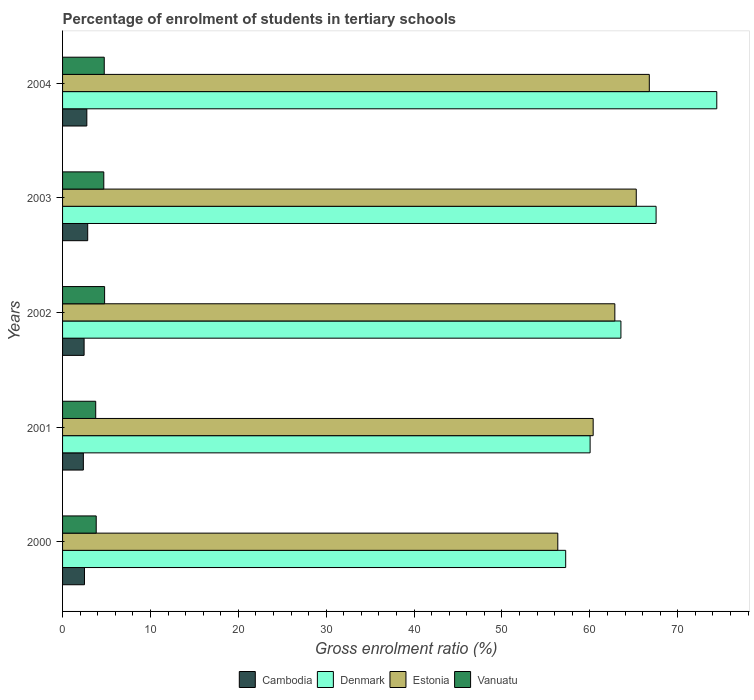How many groups of bars are there?
Offer a very short reply. 5. How many bars are there on the 2nd tick from the top?
Offer a terse response. 4. How many bars are there on the 4th tick from the bottom?
Offer a very short reply. 4. In how many cases, is the number of bars for a given year not equal to the number of legend labels?
Provide a short and direct response. 0. What is the percentage of students enrolled in tertiary schools in Vanuatu in 2003?
Your answer should be compact. 4.69. Across all years, what is the maximum percentage of students enrolled in tertiary schools in Cambodia?
Your answer should be compact. 2.86. Across all years, what is the minimum percentage of students enrolled in tertiary schools in Denmark?
Your response must be concise. 57.25. In which year was the percentage of students enrolled in tertiary schools in Denmark maximum?
Your answer should be compact. 2004. What is the total percentage of students enrolled in tertiary schools in Cambodia in the graph?
Offer a very short reply. 12.93. What is the difference between the percentage of students enrolled in tertiary schools in Estonia in 2003 and that in 2004?
Keep it short and to the point. -1.49. What is the difference between the percentage of students enrolled in tertiary schools in Cambodia in 2004 and the percentage of students enrolled in tertiary schools in Vanuatu in 2001?
Ensure brevity in your answer.  -1.01. What is the average percentage of students enrolled in tertiary schools in Vanuatu per year?
Ensure brevity in your answer.  4.36. In the year 2003, what is the difference between the percentage of students enrolled in tertiary schools in Denmark and percentage of students enrolled in tertiary schools in Cambodia?
Offer a terse response. 64.68. What is the ratio of the percentage of students enrolled in tertiary schools in Cambodia in 2002 to that in 2003?
Ensure brevity in your answer.  0.86. Is the difference between the percentage of students enrolled in tertiary schools in Denmark in 2000 and 2003 greater than the difference between the percentage of students enrolled in tertiary schools in Cambodia in 2000 and 2003?
Make the answer very short. No. What is the difference between the highest and the second highest percentage of students enrolled in tertiary schools in Denmark?
Make the answer very short. 6.91. What is the difference between the highest and the lowest percentage of students enrolled in tertiary schools in Denmark?
Your answer should be compact. 17.19. Is the sum of the percentage of students enrolled in tertiary schools in Denmark in 2000 and 2004 greater than the maximum percentage of students enrolled in tertiary schools in Estonia across all years?
Your answer should be compact. Yes. Is it the case that in every year, the sum of the percentage of students enrolled in tertiary schools in Vanuatu and percentage of students enrolled in tertiary schools in Denmark is greater than the sum of percentage of students enrolled in tertiary schools in Cambodia and percentage of students enrolled in tertiary schools in Estonia?
Your response must be concise. Yes. What does the 3rd bar from the bottom in 2000 represents?
Keep it short and to the point. Estonia. Are all the bars in the graph horizontal?
Offer a terse response. Yes. Does the graph contain any zero values?
Offer a terse response. No. What is the title of the graph?
Offer a very short reply. Percentage of enrolment of students in tertiary schools. What is the label or title of the X-axis?
Offer a terse response. Gross enrolment ratio (%). What is the label or title of the Y-axis?
Ensure brevity in your answer.  Years. What is the Gross enrolment ratio (%) in Cambodia in 2000?
Your response must be concise. 2.49. What is the Gross enrolment ratio (%) in Denmark in 2000?
Provide a succinct answer. 57.25. What is the Gross enrolment ratio (%) in Estonia in 2000?
Offer a terse response. 56.35. What is the Gross enrolment ratio (%) of Vanuatu in 2000?
Provide a short and direct response. 3.83. What is the Gross enrolment ratio (%) of Cambodia in 2001?
Offer a very short reply. 2.37. What is the Gross enrolment ratio (%) of Denmark in 2001?
Keep it short and to the point. 60.03. What is the Gross enrolment ratio (%) in Estonia in 2001?
Your answer should be compact. 60.38. What is the Gross enrolment ratio (%) in Vanuatu in 2001?
Your answer should be very brief. 3.77. What is the Gross enrolment ratio (%) in Cambodia in 2002?
Ensure brevity in your answer.  2.45. What is the Gross enrolment ratio (%) of Denmark in 2002?
Make the answer very short. 63.54. What is the Gross enrolment ratio (%) of Estonia in 2002?
Provide a short and direct response. 62.84. What is the Gross enrolment ratio (%) in Vanuatu in 2002?
Your answer should be compact. 4.78. What is the Gross enrolment ratio (%) of Cambodia in 2003?
Keep it short and to the point. 2.86. What is the Gross enrolment ratio (%) of Denmark in 2003?
Ensure brevity in your answer.  67.54. What is the Gross enrolment ratio (%) in Estonia in 2003?
Give a very brief answer. 65.28. What is the Gross enrolment ratio (%) in Vanuatu in 2003?
Your answer should be compact. 4.69. What is the Gross enrolment ratio (%) in Cambodia in 2004?
Give a very brief answer. 2.76. What is the Gross enrolment ratio (%) of Denmark in 2004?
Your answer should be compact. 74.44. What is the Gross enrolment ratio (%) of Estonia in 2004?
Your answer should be very brief. 66.77. What is the Gross enrolment ratio (%) in Vanuatu in 2004?
Offer a very short reply. 4.74. Across all years, what is the maximum Gross enrolment ratio (%) of Cambodia?
Offer a very short reply. 2.86. Across all years, what is the maximum Gross enrolment ratio (%) in Denmark?
Your answer should be compact. 74.44. Across all years, what is the maximum Gross enrolment ratio (%) in Estonia?
Give a very brief answer. 66.77. Across all years, what is the maximum Gross enrolment ratio (%) of Vanuatu?
Provide a succinct answer. 4.78. Across all years, what is the minimum Gross enrolment ratio (%) in Cambodia?
Offer a terse response. 2.37. Across all years, what is the minimum Gross enrolment ratio (%) of Denmark?
Provide a succinct answer. 57.25. Across all years, what is the minimum Gross enrolment ratio (%) in Estonia?
Your answer should be compact. 56.35. Across all years, what is the minimum Gross enrolment ratio (%) in Vanuatu?
Ensure brevity in your answer.  3.77. What is the total Gross enrolment ratio (%) in Cambodia in the graph?
Your answer should be very brief. 12.93. What is the total Gross enrolment ratio (%) in Denmark in the graph?
Provide a short and direct response. 322.79. What is the total Gross enrolment ratio (%) in Estonia in the graph?
Your answer should be compact. 311.62. What is the total Gross enrolment ratio (%) in Vanuatu in the graph?
Your answer should be very brief. 21.82. What is the difference between the Gross enrolment ratio (%) in Cambodia in 2000 and that in 2001?
Offer a terse response. 0.13. What is the difference between the Gross enrolment ratio (%) in Denmark in 2000 and that in 2001?
Provide a short and direct response. -2.78. What is the difference between the Gross enrolment ratio (%) in Estonia in 2000 and that in 2001?
Ensure brevity in your answer.  -4.03. What is the difference between the Gross enrolment ratio (%) of Vanuatu in 2000 and that in 2001?
Provide a short and direct response. 0.06. What is the difference between the Gross enrolment ratio (%) of Cambodia in 2000 and that in 2002?
Make the answer very short. 0.04. What is the difference between the Gross enrolment ratio (%) in Denmark in 2000 and that in 2002?
Your answer should be very brief. -6.29. What is the difference between the Gross enrolment ratio (%) of Estonia in 2000 and that in 2002?
Keep it short and to the point. -6.49. What is the difference between the Gross enrolment ratio (%) of Vanuatu in 2000 and that in 2002?
Provide a succinct answer. -0.95. What is the difference between the Gross enrolment ratio (%) of Cambodia in 2000 and that in 2003?
Make the answer very short. -0.37. What is the difference between the Gross enrolment ratio (%) of Denmark in 2000 and that in 2003?
Provide a short and direct response. -10.29. What is the difference between the Gross enrolment ratio (%) of Estonia in 2000 and that in 2003?
Ensure brevity in your answer.  -8.93. What is the difference between the Gross enrolment ratio (%) in Vanuatu in 2000 and that in 2003?
Your answer should be very brief. -0.86. What is the difference between the Gross enrolment ratio (%) in Cambodia in 2000 and that in 2004?
Give a very brief answer. -0.27. What is the difference between the Gross enrolment ratio (%) in Denmark in 2000 and that in 2004?
Keep it short and to the point. -17.19. What is the difference between the Gross enrolment ratio (%) in Estonia in 2000 and that in 2004?
Give a very brief answer. -10.41. What is the difference between the Gross enrolment ratio (%) of Vanuatu in 2000 and that in 2004?
Your response must be concise. -0.91. What is the difference between the Gross enrolment ratio (%) of Cambodia in 2001 and that in 2002?
Your answer should be compact. -0.08. What is the difference between the Gross enrolment ratio (%) of Denmark in 2001 and that in 2002?
Give a very brief answer. -3.51. What is the difference between the Gross enrolment ratio (%) of Estonia in 2001 and that in 2002?
Your answer should be compact. -2.47. What is the difference between the Gross enrolment ratio (%) in Vanuatu in 2001 and that in 2002?
Ensure brevity in your answer.  -1.01. What is the difference between the Gross enrolment ratio (%) in Cambodia in 2001 and that in 2003?
Provide a short and direct response. -0.49. What is the difference between the Gross enrolment ratio (%) of Denmark in 2001 and that in 2003?
Your answer should be very brief. -7.51. What is the difference between the Gross enrolment ratio (%) of Estonia in 2001 and that in 2003?
Give a very brief answer. -4.9. What is the difference between the Gross enrolment ratio (%) of Vanuatu in 2001 and that in 2003?
Your answer should be compact. -0.92. What is the difference between the Gross enrolment ratio (%) of Cambodia in 2001 and that in 2004?
Your answer should be very brief. -0.39. What is the difference between the Gross enrolment ratio (%) of Denmark in 2001 and that in 2004?
Offer a terse response. -14.41. What is the difference between the Gross enrolment ratio (%) in Estonia in 2001 and that in 2004?
Your answer should be compact. -6.39. What is the difference between the Gross enrolment ratio (%) of Vanuatu in 2001 and that in 2004?
Your response must be concise. -0.97. What is the difference between the Gross enrolment ratio (%) in Cambodia in 2002 and that in 2003?
Your answer should be compact. -0.41. What is the difference between the Gross enrolment ratio (%) in Denmark in 2002 and that in 2003?
Offer a very short reply. -4. What is the difference between the Gross enrolment ratio (%) of Estonia in 2002 and that in 2003?
Your response must be concise. -2.44. What is the difference between the Gross enrolment ratio (%) of Vanuatu in 2002 and that in 2003?
Provide a short and direct response. 0.09. What is the difference between the Gross enrolment ratio (%) in Cambodia in 2002 and that in 2004?
Give a very brief answer. -0.31. What is the difference between the Gross enrolment ratio (%) in Denmark in 2002 and that in 2004?
Give a very brief answer. -10.91. What is the difference between the Gross enrolment ratio (%) of Estonia in 2002 and that in 2004?
Your answer should be very brief. -3.92. What is the difference between the Gross enrolment ratio (%) in Vanuatu in 2002 and that in 2004?
Give a very brief answer. 0.04. What is the difference between the Gross enrolment ratio (%) of Cambodia in 2003 and that in 2004?
Provide a short and direct response. 0.1. What is the difference between the Gross enrolment ratio (%) in Denmark in 2003 and that in 2004?
Provide a short and direct response. -6.91. What is the difference between the Gross enrolment ratio (%) of Estonia in 2003 and that in 2004?
Your response must be concise. -1.49. What is the difference between the Gross enrolment ratio (%) in Vanuatu in 2003 and that in 2004?
Keep it short and to the point. -0.05. What is the difference between the Gross enrolment ratio (%) in Cambodia in 2000 and the Gross enrolment ratio (%) in Denmark in 2001?
Make the answer very short. -57.53. What is the difference between the Gross enrolment ratio (%) in Cambodia in 2000 and the Gross enrolment ratio (%) in Estonia in 2001?
Make the answer very short. -57.88. What is the difference between the Gross enrolment ratio (%) in Cambodia in 2000 and the Gross enrolment ratio (%) in Vanuatu in 2001?
Ensure brevity in your answer.  -1.28. What is the difference between the Gross enrolment ratio (%) of Denmark in 2000 and the Gross enrolment ratio (%) of Estonia in 2001?
Give a very brief answer. -3.13. What is the difference between the Gross enrolment ratio (%) of Denmark in 2000 and the Gross enrolment ratio (%) of Vanuatu in 2001?
Your answer should be compact. 53.48. What is the difference between the Gross enrolment ratio (%) in Estonia in 2000 and the Gross enrolment ratio (%) in Vanuatu in 2001?
Ensure brevity in your answer.  52.58. What is the difference between the Gross enrolment ratio (%) in Cambodia in 2000 and the Gross enrolment ratio (%) in Denmark in 2002?
Ensure brevity in your answer.  -61.04. What is the difference between the Gross enrolment ratio (%) in Cambodia in 2000 and the Gross enrolment ratio (%) in Estonia in 2002?
Your answer should be compact. -60.35. What is the difference between the Gross enrolment ratio (%) of Cambodia in 2000 and the Gross enrolment ratio (%) of Vanuatu in 2002?
Ensure brevity in your answer.  -2.29. What is the difference between the Gross enrolment ratio (%) in Denmark in 2000 and the Gross enrolment ratio (%) in Estonia in 2002?
Give a very brief answer. -5.59. What is the difference between the Gross enrolment ratio (%) of Denmark in 2000 and the Gross enrolment ratio (%) of Vanuatu in 2002?
Your response must be concise. 52.47. What is the difference between the Gross enrolment ratio (%) in Estonia in 2000 and the Gross enrolment ratio (%) in Vanuatu in 2002?
Your answer should be compact. 51.57. What is the difference between the Gross enrolment ratio (%) of Cambodia in 2000 and the Gross enrolment ratio (%) of Denmark in 2003?
Give a very brief answer. -65.04. What is the difference between the Gross enrolment ratio (%) of Cambodia in 2000 and the Gross enrolment ratio (%) of Estonia in 2003?
Keep it short and to the point. -62.79. What is the difference between the Gross enrolment ratio (%) of Cambodia in 2000 and the Gross enrolment ratio (%) of Vanuatu in 2003?
Your answer should be compact. -2.2. What is the difference between the Gross enrolment ratio (%) of Denmark in 2000 and the Gross enrolment ratio (%) of Estonia in 2003?
Provide a succinct answer. -8.03. What is the difference between the Gross enrolment ratio (%) of Denmark in 2000 and the Gross enrolment ratio (%) of Vanuatu in 2003?
Offer a terse response. 52.56. What is the difference between the Gross enrolment ratio (%) in Estonia in 2000 and the Gross enrolment ratio (%) in Vanuatu in 2003?
Ensure brevity in your answer.  51.66. What is the difference between the Gross enrolment ratio (%) in Cambodia in 2000 and the Gross enrolment ratio (%) in Denmark in 2004?
Provide a short and direct response. -71.95. What is the difference between the Gross enrolment ratio (%) of Cambodia in 2000 and the Gross enrolment ratio (%) of Estonia in 2004?
Make the answer very short. -64.27. What is the difference between the Gross enrolment ratio (%) in Cambodia in 2000 and the Gross enrolment ratio (%) in Vanuatu in 2004?
Ensure brevity in your answer.  -2.25. What is the difference between the Gross enrolment ratio (%) of Denmark in 2000 and the Gross enrolment ratio (%) of Estonia in 2004?
Provide a succinct answer. -9.52. What is the difference between the Gross enrolment ratio (%) of Denmark in 2000 and the Gross enrolment ratio (%) of Vanuatu in 2004?
Your response must be concise. 52.51. What is the difference between the Gross enrolment ratio (%) of Estonia in 2000 and the Gross enrolment ratio (%) of Vanuatu in 2004?
Ensure brevity in your answer.  51.61. What is the difference between the Gross enrolment ratio (%) of Cambodia in 2001 and the Gross enrolment ratio (%) of Denmark in 2002?
Provide a short and direct response. -61.17. What is the difference between the Gross enrolment ratio (%) of Cambodia in 2001 and the Gross enrolment ratio (%) of Estonia in 2002?
Ensure brevity in your answer.  -60.48. What is the difference between the Gross enrolment ratio (%) in Cambodia in 2001 and the Gross enrolment ratio (%) in Vanuatu in 2002?
Keep it short and to the point. -2.42. What is the difference between the Gross enrolment ratio (%) in Denmark in 2001 and the Gross enrolment ratio (%) in Estonia in 2002?
Offer a terse response. -2.82. What is the difference between the Gross enrolment ratio (%) of Denmark in 2001 and the Gross enrolment ratio (%) of Vanuatu in 2002?
Ensure brevity in your answer.  55.24. What is the difference between the Gross enrolment ratio (%) in Estonia in 2001 and the Gross enrolment ratio (%) in Vanuatu in 2002?
Provide a short and direct response. 55.59. What is the difference between the Gross enrolment ratio (%) in Cambodia in 2001 and the Gross enrolment ratio (%) in Denmark in 2003?
Make the answer very short. -65.17. What is the difference between the Gross enrolment ratio (%) in Cambodia in 2001 and the Gross enrolment ratio (%) in Estonia in 2003?
Provide a succinct answer. -62.91. What is the difference between the Gross enrolment ratio (%) in Cambodia in 2001 and the Gross enrolment ratio (%) in Vanuatu in 2003?
Offer a terse response. -2.32. What is the difference between the Gross enrolment ratio (%) of Denmark in 2001 and the Gross enrolment ratio (%) of Estonia in 2003?
Your response must be concise. -5.25. What is the difference between the Gross enrolment ratio (%) in Denmark in 2001 and the Gross enrolment ratio (%) in Vanuatu in 2003?
Give a very brief answer. 55.34. What is the difference between the Gross enrolment ratio (%) in Estonia in 2001 and the Gross enrolment ratio (%) in Vanuatu in 2003?
Make the answer very short. 55.69. What is the difference between the Gross enrolment ratio (%) in Cambodia in 2001 and the Gross enrolment ratio (%) in Denmark in 2004?
Give a very brief answer. -72.08. What is the difference between the Gross enrolment ratio (%) of Cambodia in 2001 and the Gross enrolment ratio (%) of Estonia in 2004?
Offer a terse response. -64.4. What is the difference between the Gross enrolment ratio (%) of Cambodia in 2001 and the Gross enrolment ratio (%) of Vanuatu in 2004?
Give a very brief answer. -2.38. What is the difference between the Gross enrolment ratio (%) in Denmark in 2001 and the Gross enrolment ratio (%) in Estonia in 2004?
Your answer should be very brief. -6.74. What is the difference between the Gross enrolment ratio (%) in Denmark in 2001 and the Gross enrolment ratio (%) in Vanuatu in 2004?
Offer a very short reply. 55.28. What is the difference between the Gross enrolment ratio (%) of Estonia in 2001 and the Gross enrolment ratio (%) of Vanuatu in 2004?
Offer a terse response. 55.63. What is the difference between the Gross enrolment ratio (%) in Cambodia in 2002 and the Gross enrolment ratio (%) in Denmark in 2003?
Ensure brevity in your answer.  -65.09. What is the difference between the Gross enrolment ratio (%) of Cambodia in 2002 and the Gross enrolment ratio (%) of Estonia in 2003?
Give a very brief answer. -62.83. What is the difference between the Gross enrolment ratio (%) of Cambodia in 2002 and the Gross enrolment ratio (%) of Vanuatu in 2003?
Your answer should be very brief. -2.24. What is the difference between the Gross enrolment ratio (%) in Denmark in 2002 and the Gross enrolment ratio (%) in Estonia in 2003?
Offer a very short reply. -1.75. What is the difference between the Gross enrolment ratio (%) of Denmark in 2002 and the Gross enrolment ratio (%) of Vanuatu in 2003?
Provide a succinct answer. 58.84. What is the difference between the Gross enrolment ratio (%) in Estonia in 2002 and the Gross enrolment ratio (%) in Vanuatu in 2003?
Your answer should be very brief. 58.15. What is the difference between the Gross enrolment ratio (%) in Cambodia in 2002 and the Gross enrolment ratio (%) in Denmark in 2004?
Keep it short and to the point. -71.99. What is the difference between the Gross enrolment ratio (%) of Cambodia in 2002 and the Gross enrolment ratio (%) of Estonia in 2004?
Give a very brief answer. -64.32. What is the difference between the Gross enrolment ratio (%) in Cambodia in 2002 and the Gross enrolment ratio (%) in Vanuatu in 2004?
Offer a very short reply. -2.29. What is the difference between the Gross enrolment ratio (%) in Denmark in 2002 and the Gross enrolment ratio (%) in Estonia in 2004?
Offer a very short reply. -3.23. What is the difference between the Gross enrolment ratio (%) of Denmark in 2002 and the Gross enrolment ratio (%) of Vanuatu in 2004?
Offer a terse response. 58.79. What is the difference between the Gross enrolment ratio (%) in Estonia in 2002 and the Gross enrolment ratio (%) in Vanuatu in 2004?
Give a very brief answer. 58.1. What is the difference between the Gross enrolment ratio (%) in Cambodia in 2003 and the Gross enrolment ratio (%) in Denmark in 2004?
Give a very brief answer. -71.58. What is the difference between the Gross enrolment ratio (%) of Cambodia in 2003 and the Gross enrolment ratio (%) of Estonia in 2004?
Keep it short and to the point. -63.91. What is the difference between the Gross enrolment ratio (%) of Cambodia in 2003 and the Gross enrolment ratio (%) of Vanuatu in 2004?
Give a very brief answer. -1.88. What is the difference between the Gross enrolment ratio (%) in Denmark in 2003 and the Gross enrolment ratio (%) in Estonia in 2004?
Ensure brevity in your answer.  0.77. What is the difference between the Gross enrolment ratio (%) in Denmark in 2003 and the Gross enrolment ratio (%) in Vanuatu in 2004?
Give a very brief answer. 62.79. What is the difference between the Gross enrolment ratio (%) in Estonia in 2003 and the Gross enrolment ratio (%) in Vanuatu in 2004?
Make the answer very short. 60.54. What is the average Gross enrolment ratio (%) in Cambodia per year?
Offer a terse response. 2.59. What is the average Gross enrolment ratio (%) of Denmark per year?
Make the answer very short. 64.56. What is the average Gross enrolment ratio (%) in Estonia per year?
Offer a terse response. 62.32. What is the average Gross enrolment ratio (%) of Vanuatu per year?
Keep it short and to the point. 4.36. In the year 2000, what is the difference between the Gross enrolment ratio (%) in Cambodia and Gross enrolment ratio (%) in Denmark?
Keep it short and to the point. -54.76. In the year 2000, what is the difference between the Gross enrolment ratio (%) of Cambodia and Gross enrolment ratio (%) of Estonia?
Keep it short and to the point. -53.86. In the year 2000, what is the difference between the Gross enrolment ratio (%) of Cambodia and Gross enrolment ratio (%) of Vanuatu?
Your answer should be very brief. -1.34. In the year 2000, what is the difference between the Gross enrolment ratio (%) in Denmark and Gross enrolment ratio (%) in Estonia?
Make the answer very short. 0.9. In the year 2000, what is the difference between the Gross enrolment ratio (%) of Denmark and Gross enrolment ratio (%) of Vanuatu?
Provide a short and direct response. 53.42. In the year 2000, what is the difference between the Gross enrolment ratio (%) of Estonia and Gross enrolment ratio (%) of Vanuatu?
Offer a very short reply. 52.52. In the year 2001, what is the difference between the Gross enrolment ratio (%) of Cambodia and Gross enrolment ratio (%) of Denmark?
Ensure brevity in your answer.  -57.66. In the year 2001, what is the difference between the Gross enrolment ratio (%) in Cambodia and Gross enrolment ratio (%) in Estonia?
Offer a very short reply. -58.01. In the year 2001, what is the difference between the Gross enrolment ratio (%) of Cambodia and Gross enrolment ratio (%) of Vanuatu?
Provide a succinct answer. -1.41. In the year 2001, what is the difference between the Gross enrolment ratio (%) in Denmark and Gross enrolment ratio (%) in Estonia?
Provide a short and direct response. -0.35. In the year 2001, what is the difference between the Gross enrolment ratio (%) in Denmark and Gross enrolment ratio (%) in Vanuatu?
Provide a succinct answer. 56.26. In the year 2001, what is the difference between the Gross enrolment ratio (%) in Estonia and Gross enrolment ratio (%) in Vanuatu?
Make the answer very short. 56.6. In the year 2002, what is the difference between the Gross enrolment ratio (%) in Cambodia and Gross enrolment ratio (%) in Denmark?
Make the answer very short. -61.08. In the year 2002, what is the difference between the Gross enrolment ratio (%) in Cambodia and Gross enrolment ratio (%) in Estonia?
Offer a terse response. -60.39. In the year 2002, what is the difference between the Gross enrolment ratio (%) of Cambodia and Gross enrolment ratio (%) of Vanuatu?
Your answer should be very brief. -2.33. In the year 2002, what is the difference between the Gross enrolment ratio (%) of Denmark and Gross enrolment ratio (%) of Estonia?
Make the answer very short. 0.69. In the year 2002, what is the difference between the Gross enrolment ratio (%) of Denmark and Gross enrolment ratio (%) of Vanuatu?
Provide a succinct answer. 58.75. In the year 2002, what is the difference between the Gross enrolment ratio (%) in Estonia and Gross enrolment ratio (%) in Vanuatu?
Offer a very short reply. 58.06. In the year 2003, what is the difference between the Gross enrolment ratio (%) of Cambodia and Gross enrolment ratio (%) of Denmark?
Give a very brief answer. -64.68. In the year 2003, what is the difference between the Gross enrolment ratio (%) in Cambodia and Gross enrolment ratio (%) in Estonia?
Offer a terse response. -62.42. In the year 2003, what is the difference between the Gross enrolment ratio (%) in Cambodia and Gross enrolment ratio (%) in Vanuatu?
Your answer should be very brief. -1.83. In the year 2003, what is the difference between the Gross enrolment ratio (%) of Denmark and Gross enrolment ratio (%) of Estonia?
Make the answer very short. 2.26. In the year 2003, what is the difference between the Gross enrolment ratio (%) in Denmark and Gross enrolment ratio (%) in Vanuatu?
Make the answer very short. 62.85. In the year 2003, what is the difference between the Gross enrolment ratio (%) of Estonia and Gross enrolment ratio (%) of Vanuatu?
Give a very brief answer. 60.59. In the year 2004, what is the difference between the Gross enrolment ratio (%) in Cambodia and Gross enrolment ratio (%) in Denmark?
Ensure brevity in your answer.  -71.68. In the year 2004, what is the difference between the Gross enrolment ratio (%) of Cambodia and Gross enrolment ratio (%) of Estonia?
Your answer should be compact. -64.01. In the year 2004, what is the difference between the Gross enrolment ratio (%) of Cambodia and Gross enrolment ratio (%) of Vanuatu?
Your answer should be compact. -1.98. In the year 2004, what is the difference between the Gross enrolment ratio (%) of Denmark and Gross enrolment ratio (%) of Estonia?
Offer a terse response. 7.68. In the year 2004, what is the difference between the Gross enrolment ratio (%) of Denmark and Gross enrolment ratio (%) of Vanuatu?
Your answer should be compact. 69.7. In the year 2004, what is the difference between the Gross enrolment ratio (%) in Estonia and Gross enrolment ratio (%) in Vanuatu?
Provide a succinct answer. 62.02. What is the ratio of the Gross enrolment ratio (%) in Cambodia in 2000 to that in 2001?
Your answer should be compact. 1.05. What is the ratio of the Gross enrolment ratio (%) in Denmark in 2000 to that in 2001?
Offer a very short reply. 0.95. What is the ratio of the Gross enrolment ratio (%) in Vanuatu in 2000 to that in 2001?
Give a very brief answer. 1.01. What is the ratio of the Gross enrolment ratio (%) in Cambodia in 2000 to that in 2002?
Offer a terse response. 1.02. What is the ratio of the Gross enrolment ratio (%) of Denmark in 2000 to that in 2002?
Offer a very short reply. 0.9. What is the ratio of the Gross enrolment ratio (%) of Estonia in 2000 to that in 2002?
Make the answer very short. 0.9. What is the ratio of the Gross enrolment ratio (%) of Vanuatu in 2000 to that in 2002?
Keep it short and to the point. 0.8. What is the ratio of the Gross enrolment ratio (%) in Cambodia in 2000 to that in 2003?
Keep it short and to the point. 0.87. What is the ratio of the Gross enrolment ratio (%) in Denmark in 2000 to that in 2003?
Offer a terse response. 0.85. What is the ratio of the Gross enrolment ratio (%) of Estonia in 2000 to that in 2003?
Your answer should be very brief. 0.86. What is the ratio of the Gross enrolment ratio (%) in Vanuatu in 2000 to that in 2003?
Provide a short and direct response. 0.82. What is the ratio of the Gross enrolment ratio (%) of Cambodia in 2000 to that in 2004?
Offer a terse response. 0.9. What is the ratio of the Gross enrolment ratio (%) of Denmark in 2000 to that in 2004?
Ensure brevity in your answer.  0.77. What is the ratio of the Gross enrolment ratio (%) of Estonia in 2000 to that in 2004?
Provide a succinct answer. 0.84. What is the ratio of the Gross enrolment ratio (%) of Vanuatu in 2000 to that in 2004?
Your answer should be compact. 0.81. What is the ratio of the Gross enrolment ratio (%) of Cambodia in 2001 to that in 2002?
Offer a terse response. 0.97. What is the ratio of the Gross enrolment ratio (%) of Denmark in 2001 to that in 2002?
Provide a succinct answer. 0.94. What is the ratio of the Gross enrolment ratio (%) in Estonia in 2001 to that in 2002?
Keep it short and to the point. 0.96. What is the ratio of the Gross enrolment ratio (%) of Vanuatu in 2001 to that in 2002?
Give a very brief answer. 0.79. What is the ratio of the Gross enrolment ratio (%) in Cambodia in 2001 to that in 2003?
Ensure brevity in your answer.  0.83. What is the ratio of the Gross enrolment ratio (%) in Denmark in 2001 to that in 2003?
Give a very brief answer. 0.89. What is the ratio of the Gross enrolment ratio (%) of Estonia in 2001 to that in 2003?
Make the answer very short. 0.92. What is the ratio of the Gross enrolment ratio (%) of Vanuatu in 2001 to that in 2003?
Keep it short and to the point. 0.8. What is the ratio of the Gross enrolment ratio (%) in Cambodia in 2001 to that in 2004?
Give a very brief answer. 0.86. What is the ratio of the Gross enrolment ratio (%) in Denmark in 2001 to that in 2004?
Your answer should be compact. 0.81. What is the ratio of the Gross enrolment ratio (%) in Estonia in 2001 to that in 2004?
Make the answer very short. 0.9. What is the ratio of the Gross enrolment ratio (%) of Vanuatu in 2001 to that in 2004?
Make the answer very short. 0.8. What is the ratio of the Gross enrolment ratio (%) in Cambodia in 2002 to that in 2003?
Your answer should be compact. 0.86. What is the ratio of the Gross enrolment ratio (%) in Denmark in 2002 to that in 2003?
Provide a short and direct response. 0.94. What is the ratio of the Gross enrolment ratio (%) of Estonia in 2002 to that in 2003?
Offer a very short reply. 0.96. What is the ratio of the Gross enrolment ratio (%) of Vanuatu in 2002 to that in 2003?
Your response must be concise. 1.02. What is the ratio of the Gross enrolment ratio (%) in Cambodia in 2002 to that in 2004?
Make the answer very short. 0.89. What is the ratio of the Gross enrolment ratio (%) in Denmark in 2002 to that in 2004?
Make the answer very short. 0.85. What is the ratio of the Gross enrolment ratio (%) in Estonia in 2002 to that in 2004?
Your answer should be compact. 0.94. What is the ratio of the Gross enrolment ratio (%) of Vanuatu in 2002 to that in 2004?
Give a very brief answer. 1.01. What is the ratio of the Gross enrolment ratio (%) of Cambodia in 2003 to that in 2004?
Make the answer very short. 1.04. What is the ratio of the Gross enrolment ratio (%) in Denmark in 2003 to that in 2004?
Offer a very short reply. 0.91. What is the ratio of the Gross enrolment ratio (%) of Estonia in 2003 to that in 2004?
Ensure brevity in your answer.  0.98. What is the ratio of the Gross enrolment ratio (%) of Vanuatu in 2003 to that in 2004?
Make the answer very short. 0.99. What is the difference between the highest and the second highest Gross enrolment ratio (%) of Cambodia?
Ensure brevity in your answer.  0.1. What is the difference between the highest and the second highest Gross enrolment ratio (%) in Denmark?
Offer a terse response. 6.91. What is the difference between the highest and the second highest Gross enrolment ratio (%) of Estonia?
Provide a short and direct response. 1.49. What is the difference between the highest and the second highest Gross enrolment ratio (%) in Vanuatu?
Give a very brief answer. 0.04. What is the difference between the highest and the lowest Gross enrolment ratio (%) of Cambodia?
Your answer should be compact. 0.49. What is the difference between the highest and the lowest Gross enrolment ratio (%) of Denmark?
Keep it short and to the point. 17.19. What is the difference between the highest and the lowest Gross enrolment ratio (%) of Estonia?
Give a very brief answer. 10.41. What is the difference between the highest and the lowest Gross enrolment ratio (%) of Vanuatu?
Ensure brevity in your answer.  1.01. 